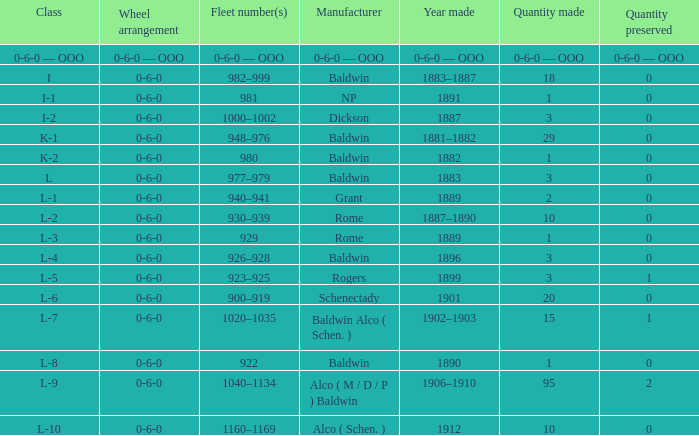Which Class has a Quantity made of 29? K-1. 